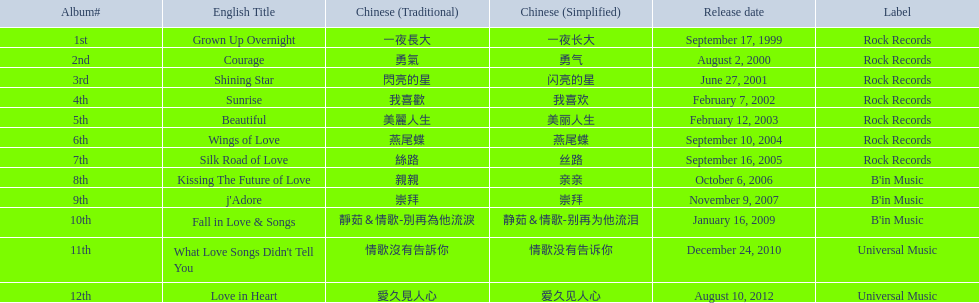What is the title of her most recent album created with rock records? Silk Road of Love. Can you give me this table as a dict? {'header': ['Album#', 'English Title', 'Chinese (Traditional)', 'Chinese (Simplified)', 'Release date', 'Label'], 'rows': [['1st', 'Grown Up Overnight', '一夜長大', '一夜长大', 'September 17, 1999', 'Rock Records'], ['2nd', 'Courage', '勇氣', '勇气', 'August 2, 2000', 'Rock Records'], ['3rd', 'Shining Star', '閃亮的星', '闪亮的星', 'June 27, 2001', 'Rock Records'], ['4th', 'Sunrise', '我喜歡', '我喜欢', 'February 7, 2002', 'Rock Records'], ['5th', 'Beautiful', '美麗人生', '美丽人生', 'February 12, 2003', 'Rock Records'], ['6th', 'Wings of Love', '燕尾蝶', '燕尾蝶', 'September 10, 2004', 'Rock Records'], ['7th', 'Silk Road of Love', '絲路', '丝路', 'September 16, 2005', 'Rock Records'], ['8th', 'Kissing The Future of Love', '親親', '亲亲', 'October 6, 2006', "B'in Music"], ['9th', "j'Adore", '崇拜', '崇拜', 'November 9, 2007', "B'in Music"], ['10th', 'Fall in Love & Songs', '靜茹＆情歌-別再為他流淚', '静茹＆情歌-别再为他流泪', 'January 16, 2009', "B'in Music"], ['11th', "What Love Songs Didn't Tell You", '情歌沒有告訴你', '情歌没有告诉你', 'December 24, 2010', 'Universal Music'], ['12th', 'Love in Heart', '愛久見人心', '爱久见人心', 'August 10, 2012', 'Universal Music']]} 